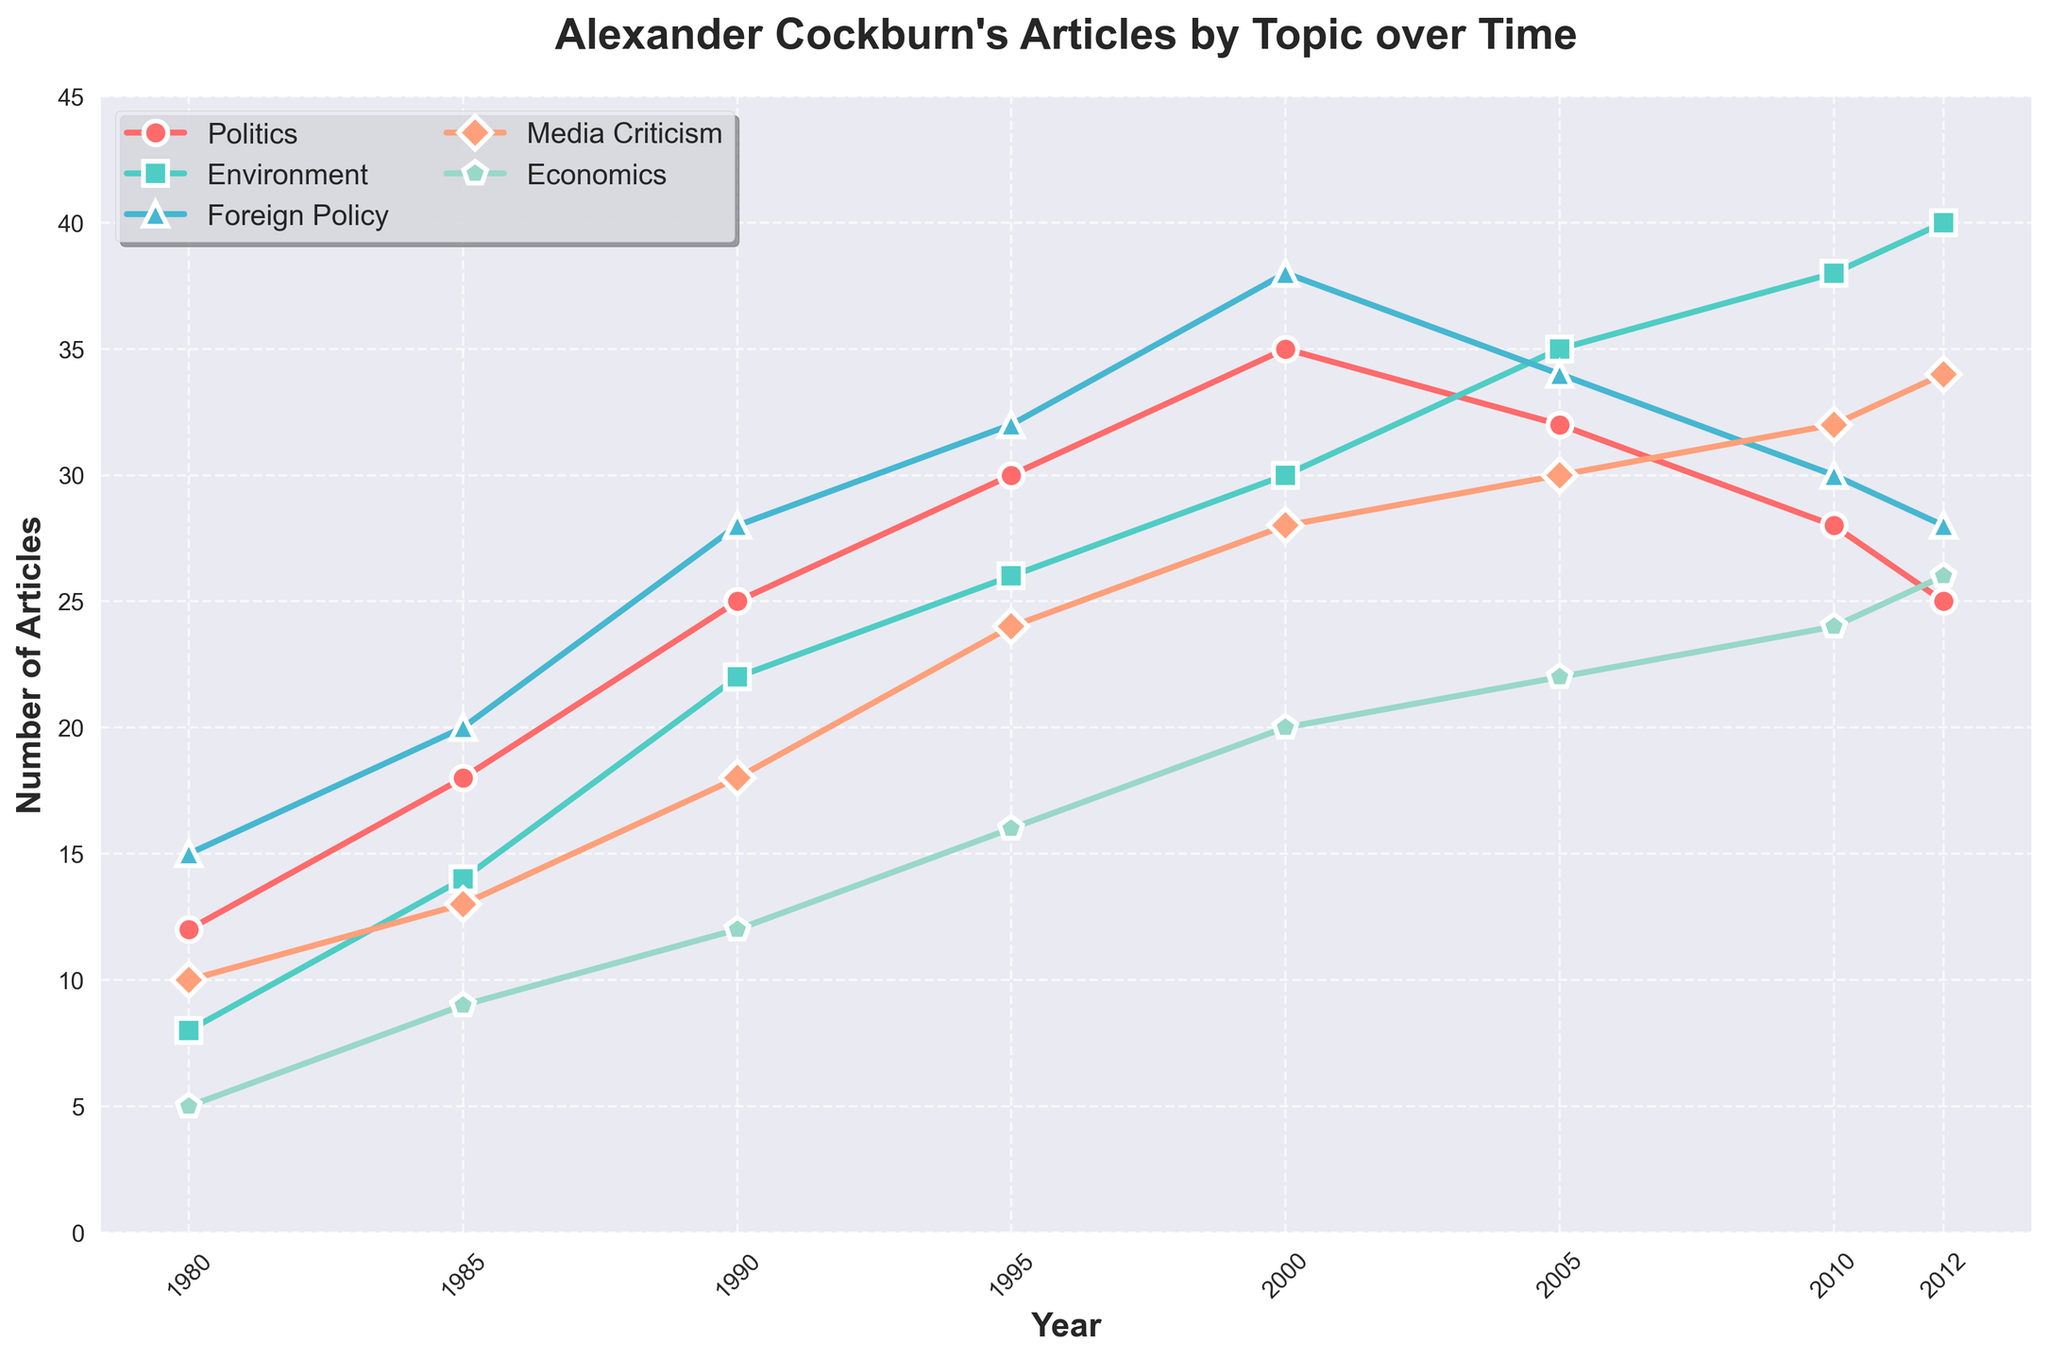How does the frequency of articles on Politics compare between 1985 and 2010? In 1985, the number of articles on Politics was 18. By 2010, it had decreased to 28. To compare, we evaluate the increase: 28 - 18 = 10. Thus, there was an increase of 10 articles over this period.
Answer: The number of Politics articles increased by 10 Which topic saw the largest increase in article frequency between 1980 and 2012? By comparing the frequency of articles for each topic between 1980 and 2012: Politics increased from 12 to 25 (13), Environment from 8 to 40 (32), Foreign Policy from 15 to 28 (13), Media Criticism from 10 to 34 (24), and Economics from 5 to 26 (21). The Environment had the largest increase: 32 articles.
Answer: Environment What is the sum of articles written on Environment and Foreign Policy in 2005? From the figure, in 2005, there are 35 articles on Environment and 34 on Foreign Policy. Sum these values: 35 + 34 = 69.
Answer: 69 Between which consecutive years did Media Criticism articles show the greatest increase? Evaluate the differences between consecutive measurements: from 1980-1985 (3), 1985-1990 (5), 1990-1995 (6), 1995-2000 (4), 2000-2005 (2), 2005-2010 (2), and 2010-2012 (2). The greatest increase is observed between 1990 and 1995 with an increase of 6 articles.
Answer: Between 1990 and 1995 During which year was the number of Economics articles equal to the number of articles on Media Criticism? By comparing the frequencies of Economics and Media Criticism over the years: Economics (5, 9, 12, 16, 20, 22, 24, 26) and Media Criticism (10, 13, 18, 24, 28, 30, 32, 34). Both Media Criticism and Economics had 30 articles in 2005 and 34 in 2012. Hence, they were equal in 2012.
Answer: 2012 Which year had the highest number of articles on Foreign Policy and by how much more was it than the corresponding year with the highest Politics articles? The highest number of articles on Foreign Policy is in 2000, with 38 articles. The corresponding highest year for Politics is also 2000, with 35 articles. Calculate the difference: 38 - 35 = 3.
Answer: 2000, by 3 articles Considering all the topics together, how many total articles were published in 1995? Sum up the number of articles for each topic in 1995: Politics (30), Environment (26), Foreign Policy (32), Media Criticism (24), and Economics (16). Calculate the total: 30 + 26 + 32 + 24 + 16 = 128.
Answer: 128 What is the average number of Environment articles published over the recorded years? Total the number of Environment articles over each year and divide by the number of years: (8 + 14 + 22 + 26 + 30 + 35 + 38 + 40) / 8. Calculate: 213 / 8 = 26.625, which rounds to 26.63.
Answer: 26.63 Of the five topics, which one had the smallest variance in article frequency over the years? Variance measures the spread of data points. Calculate the variances: Politics (63.89), Environment (94.23), Foreign Policy (62.70), Media Criticism (87.39), Economics (64.70). Foreign Policy has the smallest variance.
Answer: Foreign Policy 